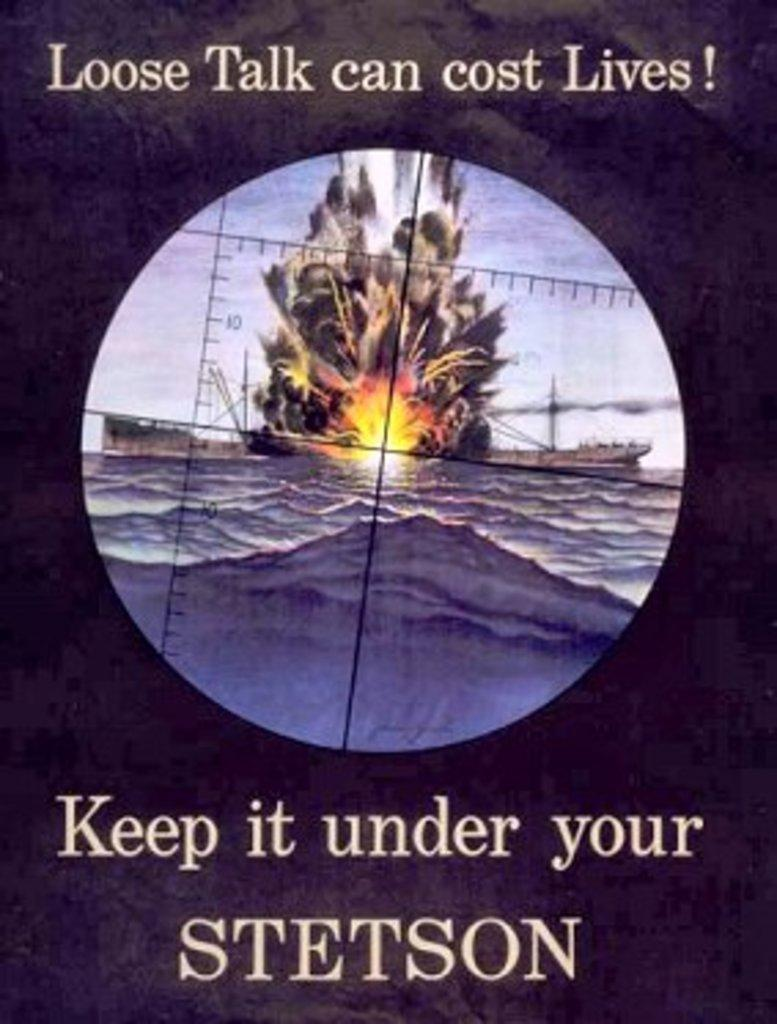<image>
Render a clear and concise summary of the photo. poster showing a ship getting bombed and words at top loose talk can cost lives 